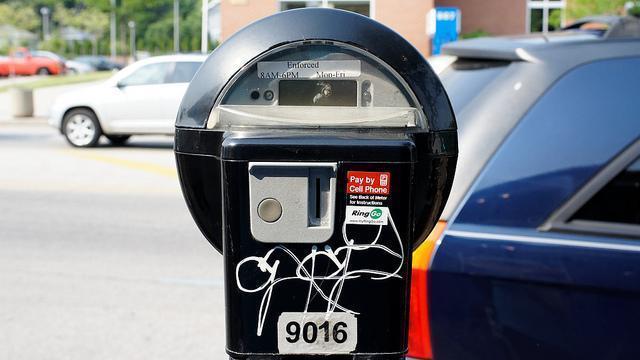What would someone need to do to use this device?
From the following four choices, select the correct answer to address the question.
Options: Ask, dance, crime, park. Park. 